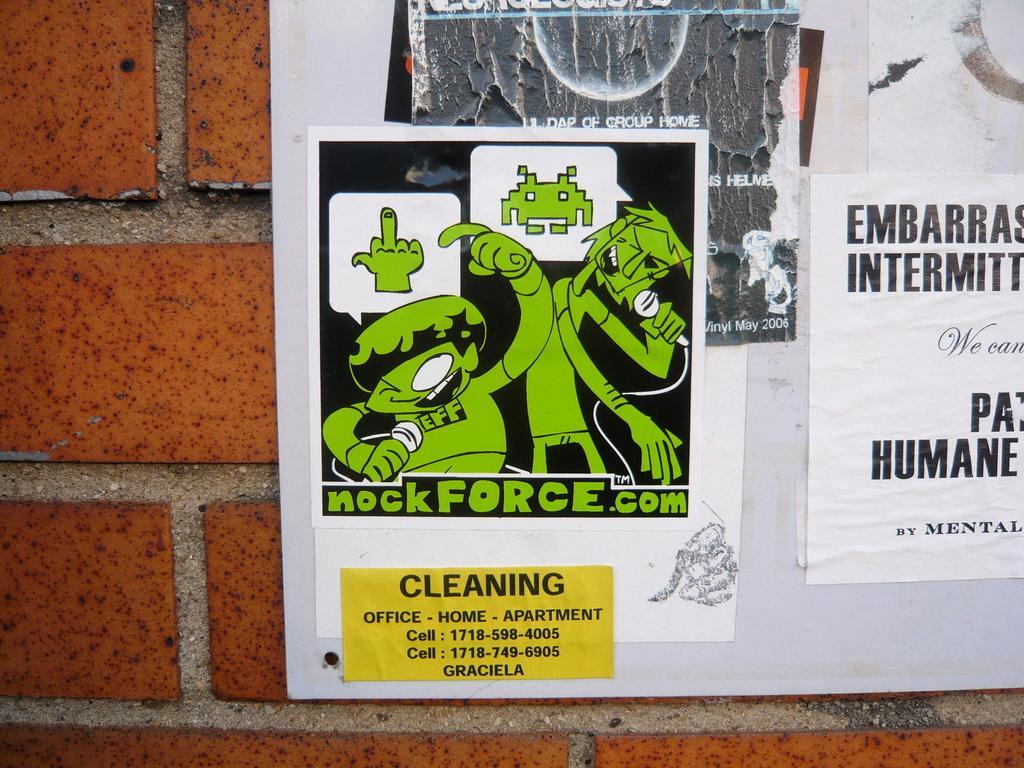Please provide a concise description of this image. In this picture I can observe posters on the white color notice board. The notice board is fixed to the wall. 